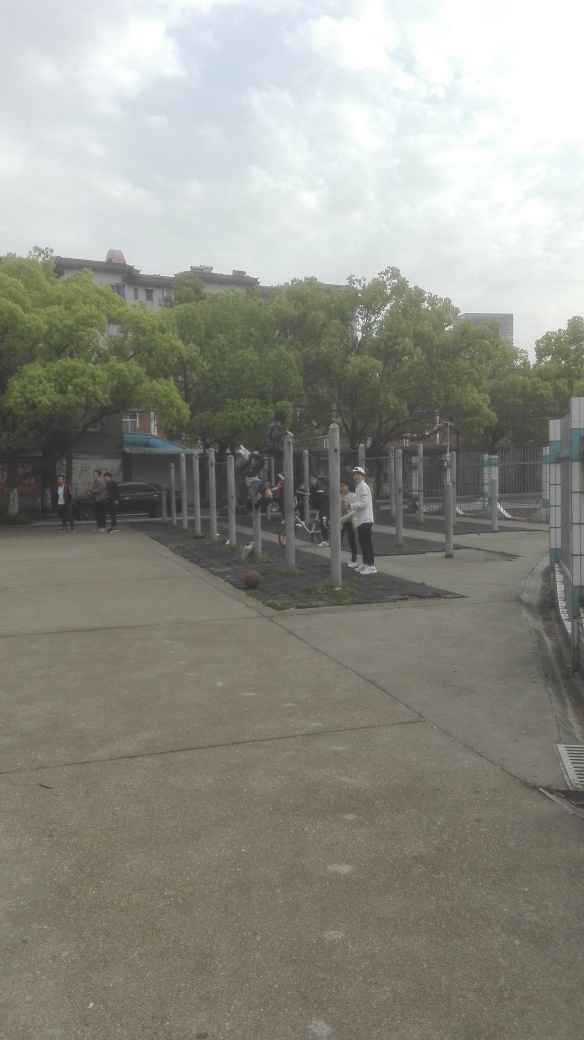What kind of activities are being carried out in this image? The image shows an outdoor fitness area where several individuals are engaged in physical exercise. There are people using the exercise bars for pull-ups and others standing or walking around, possibly taking a break or deciding what exercise to do next. 